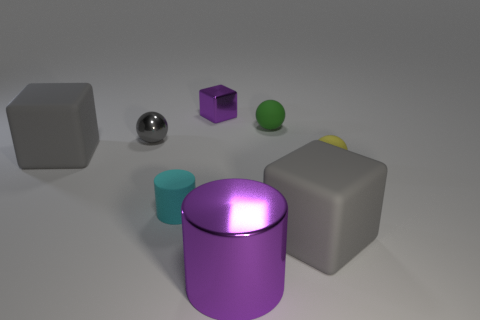There is a tiny ball that is in front of the small gray object; what color is it?
Provide a succinct answer. Yellow. What number of metal objects are purple cylinders or yellow objects?
Make the answer very short. 1. What is the material of the large block that is on the right side of the big gray rubber block left of the gray shiny thing?
Your answer should be very brief. Rubber. What material is the block that is the same color as the big shiny cylinder?
Make the answer very short. Metal. What is the color of the large metallic cylinder?
Offer a terse response. Purple. Is there a big gray rubber block that is in front of the large gray object to the left of the tiny green matte sphere?
Offer a terse response. Yes. What is the material of the green object?
Your answer should be very brief. Rubber. Does the gray ball that is on the left side of the tiny yellow thing have the same material as the purple thing behind the big purple shiny cylinder?
Make the answer very short. Yes. Are there any other things that are the same color as the shiny block?
Give a very brief answer. Yes. What color is the tiny rubber thing that is the same shape as the big purple thing?
Your answer should be compact. Cyan. 